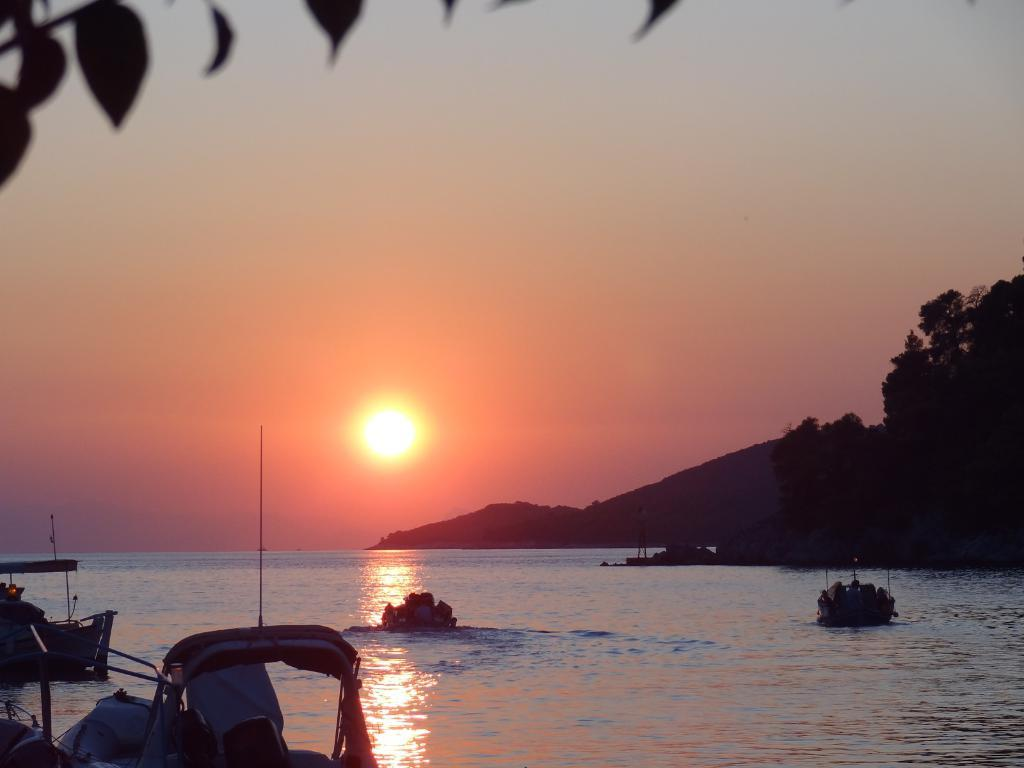What is on the water in the image? There are boats on the water in the image. What objects can be seen in the image besides the boats? There are poles in the image. What can be seen in the background of the image? There are trees, mountains, and the sun visible in the sky in the background of the image. Where are the leaves located in the image? The leaves are visible on the left side at the top of the image. What type of swing can be seen in the image? There is no swing present in the image. What is the primary interest of the trees in the background? Trees do not have interests; they are inanimate objects. 